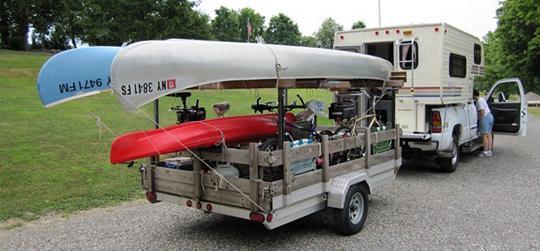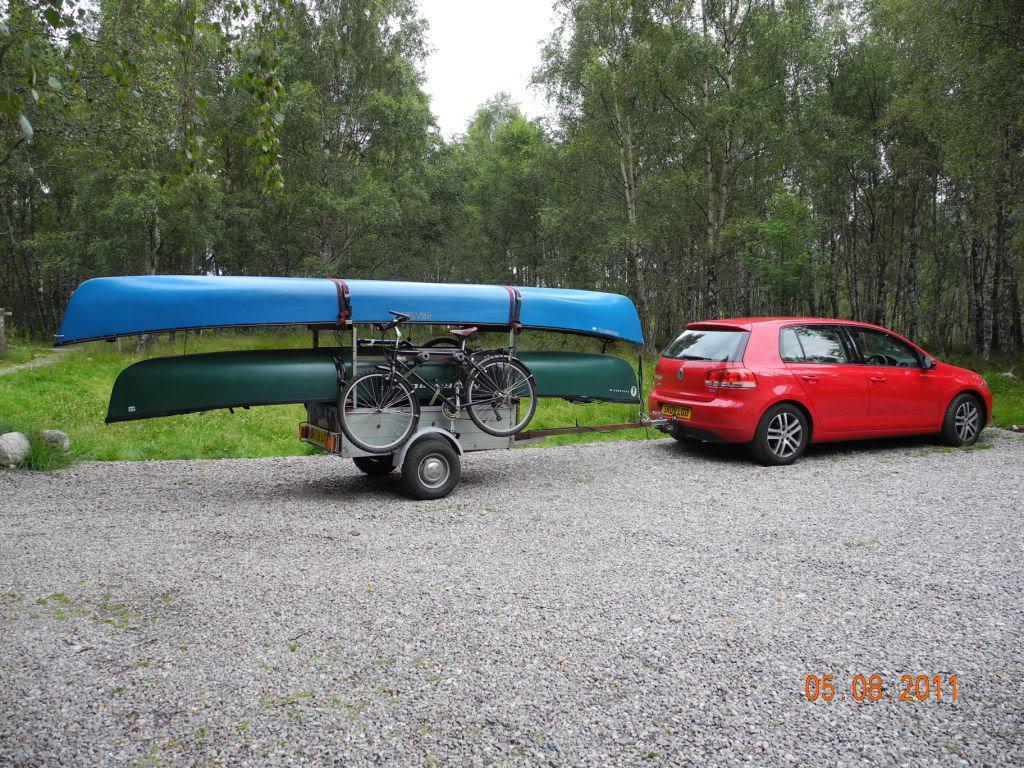The first image is the image on the left, the second image is the image on the right. Given the left and right images, does the statement "One of the trailers is rectangular in shape." hold true? Answer yes or no. Yes. The first image is the image on the left, the second image is the image on the right. For the images shown, is this caption "An image shows an unattached trailer loaded with only two canoes." true? Answer yes or no. No. 